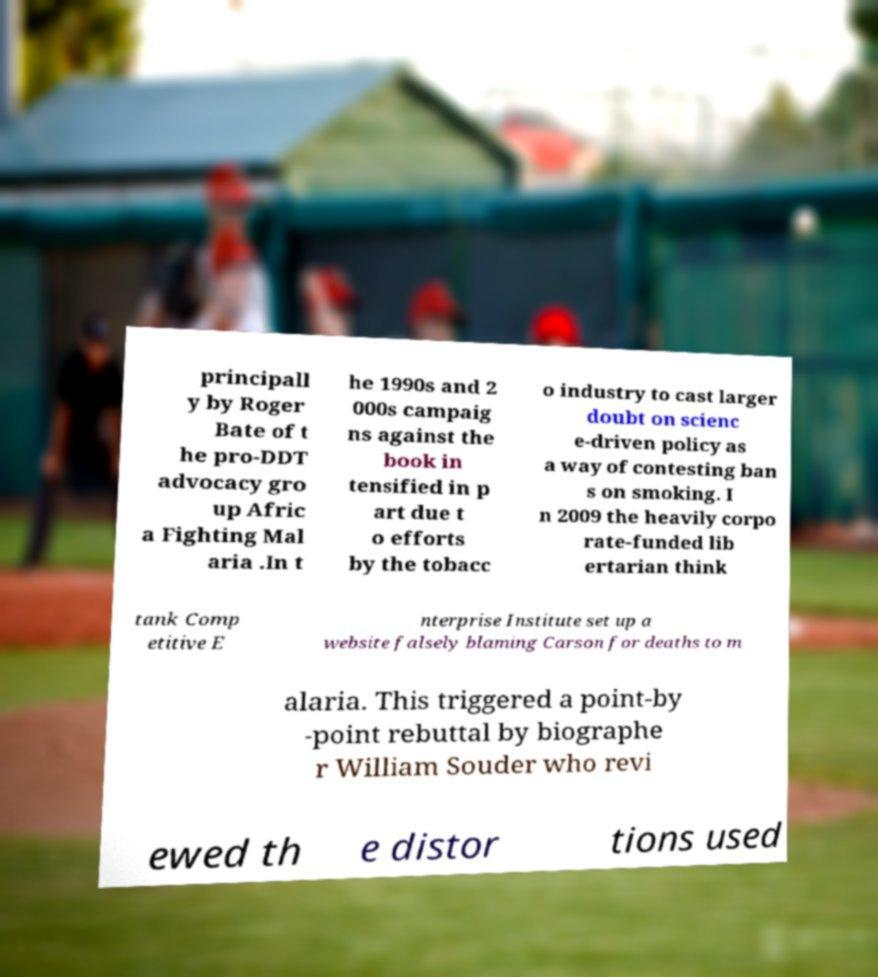Please read and relay the text visible in this image. What does it say? principall y by Roger Bate of t he pro-DDT advocacy gro up Afric a Fighting Mal aria .In t he 1990s and 2 000s campaig ns against the book in tensified in p art due t o efforts by the tobacc o industry to cast larger doubt on scienc e-driven policy as a way of contesting ban s on smoking. I n 2009 the heavily corpo rate-funded lib ertarian think tank Comp etitive E nterprise Institute set up a website falsely blaming Carson for deaths to m alaria. This triggered a point-by -point rebuttal by biographe r William Souder who revi ewed th e distor tions used 